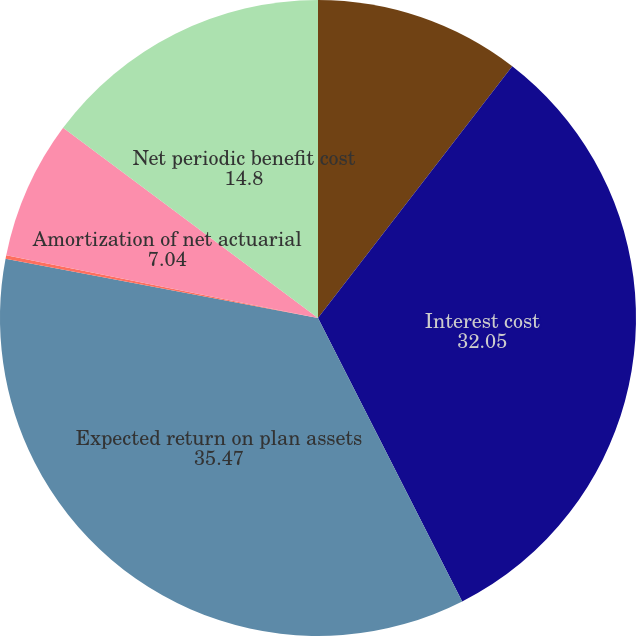<chart> <loc_0><loc_0><loc_500><loc_500><pie_chart><fcel>Service cost<fcel>Interest cost<fcel>Expected return on plan assets<fcel>Amortization of net prior<fcel>Amortization of net actuarial<fcel>Net periodic benefit cost<nl><fcel>10.46%<fcel>32.05%<fcel>35.47%<fcel>0.18%<fcel>7.04%<fcel>14.8%<nl></chart> 